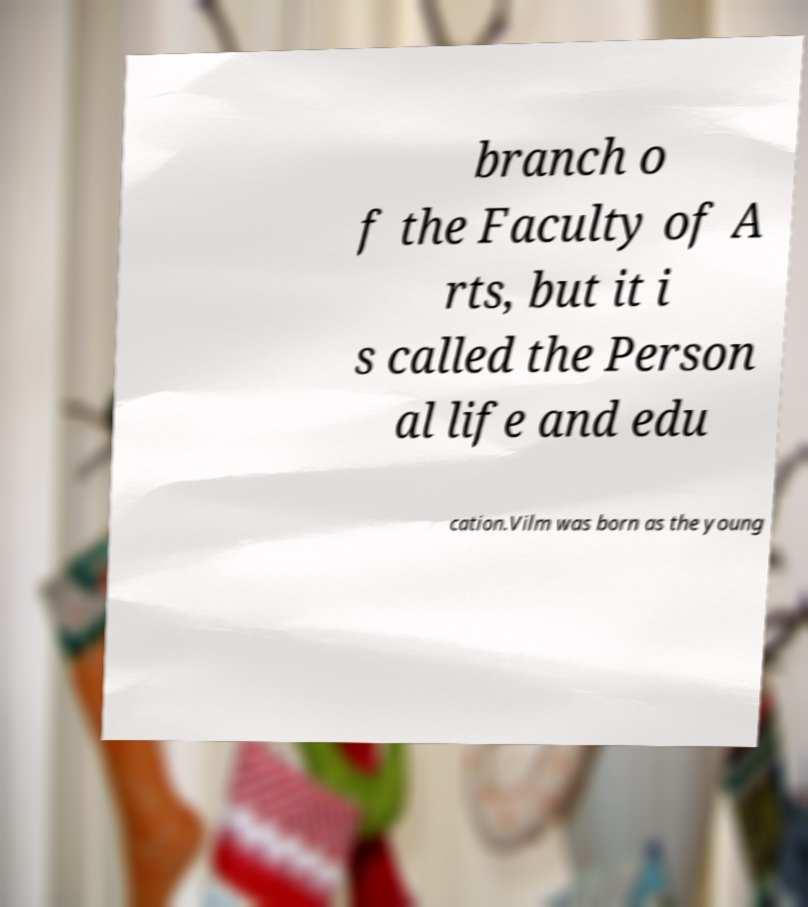Can you read and provide the text displayed in the image?This photo seems to have some interesting text. Can you extract and type it out for me? branch o f the Faculty of A rts, but it i s called the Person al life and edu cation.Vilm was born as the young 